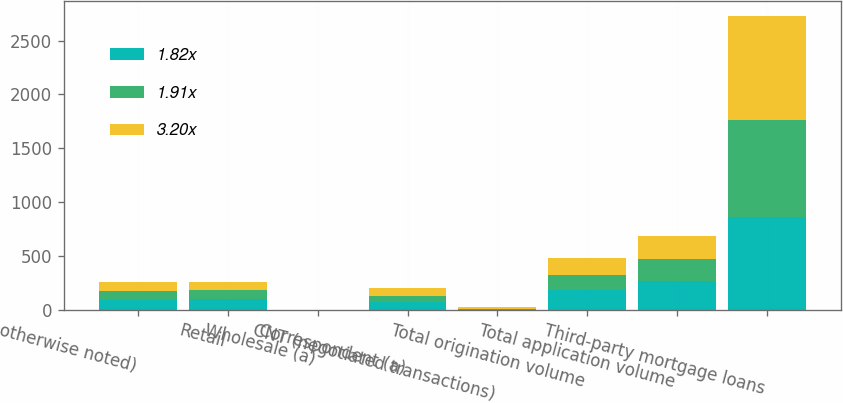Convert chart. <chart><loc_0><loc_0><loc_500><loc_500><stacked_bar_chart><ecel><fcel>otherwise noted)<fcel>Retail<fcel>Wholesale (a)<fcel>Correspondent (a)<fcel>CNT (negotiated transactions)<fcel>Total origination volume<fcel>Total application volume<fcel>Third-party mortgage loans<nl><fcel>1.82x<fcel>87.2<fcel>101.4<fcel>0.3<fcel>73.1<fcel>6<fcel>180.8<fcel>265.7<fcel>859.4<nl><fcel>1.91x<fcel>87.2<fcel>87.2<fcel>0.5<fcel>52.1<fcel>5.8<fcel>145.6<fcel>204.7<fcel>902.2<nl><fcel>3.20x<fcel>87.2<fcel>68.8<fcel>1.3<fcel>75.3<fcel>10.2<fcel>155.6<fcel>214.8<fcel>967.5<nl></chart> 